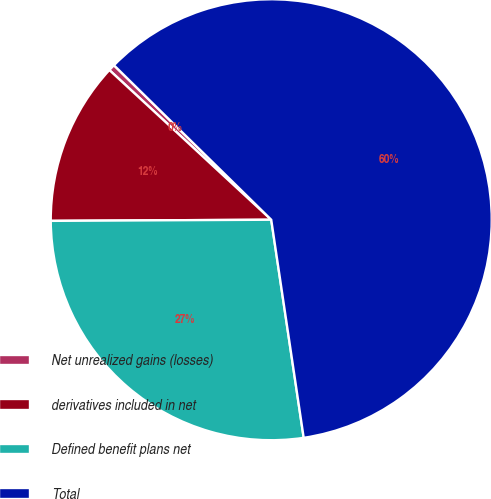Convert chart to OTSL. <chart><loc_0><loc_0><loc_500><loc_500><pie_chart><fcel>Net unrealized gains (losses)<fcel>derivatives included in net<fcel>Defined benefit plans net<fcel>Total<nl><fcel>0.48%<fcel>11.96%<fcel>27.27%<fcel>60.29%<nl></chart> 